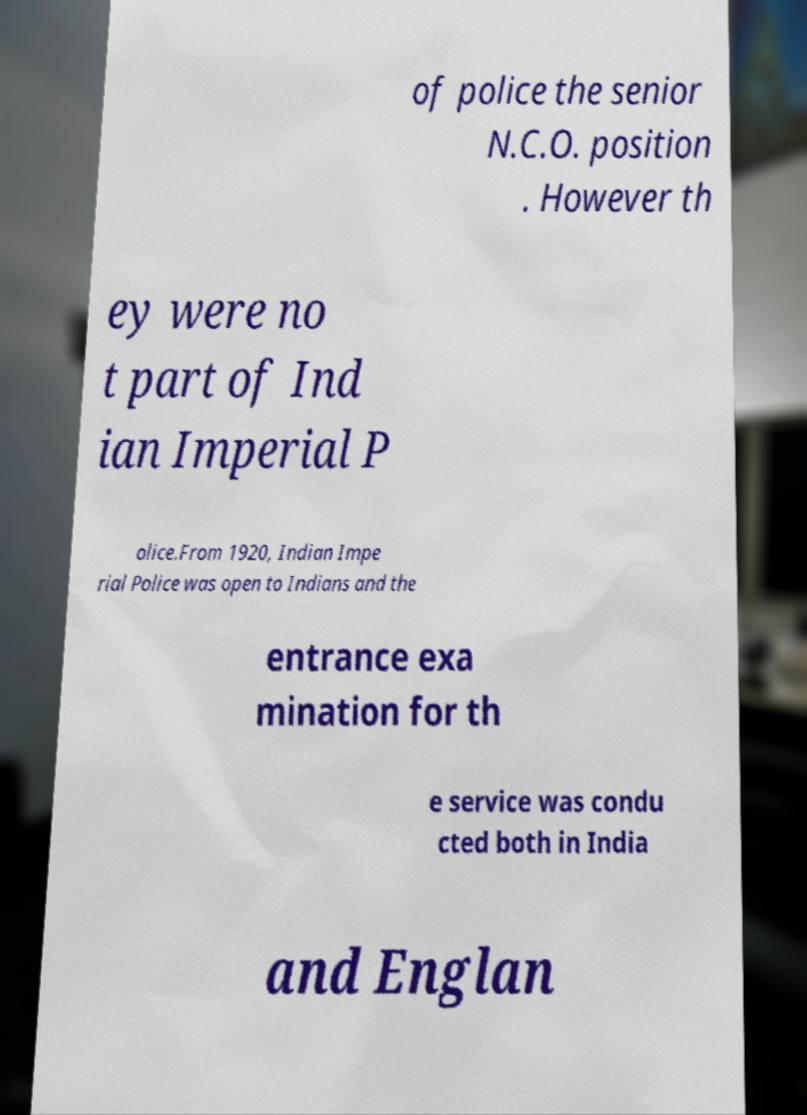What messages or text are displayed in this image? I need them in a readable, typed format. of police the senior N.C.O. position . However th ey were no t part of Ind ian Imperial P olice.From 1920, Indian Impe rial Police was open to Indians and the entrance exa mination for th e service was condu cted both in India and Englan 